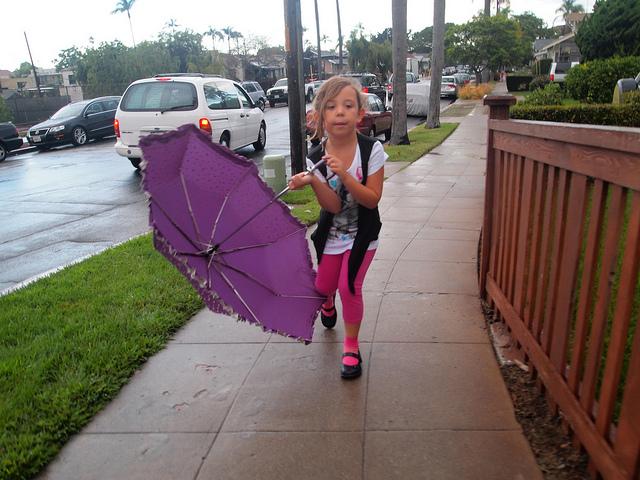Is it a  windy day?
Be succinct. Yes. What is the girl holding in her hands?
Give a very brief answer. Umbrella. Does her outfit match?
Quick response, please. Yes. 